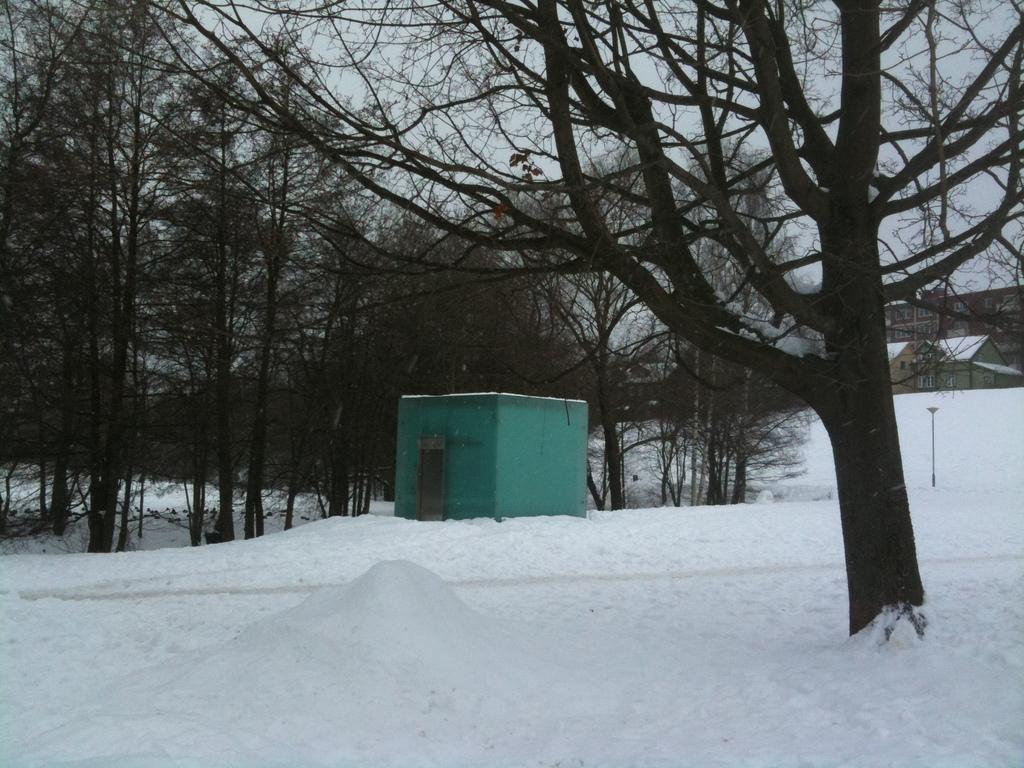Please provide a concise description of this image. In this picture in the front there is snow on the ground and there is a dry tree. In the background there is a house and there are trees and the sky is cloudy and there are buildings on the right side. 